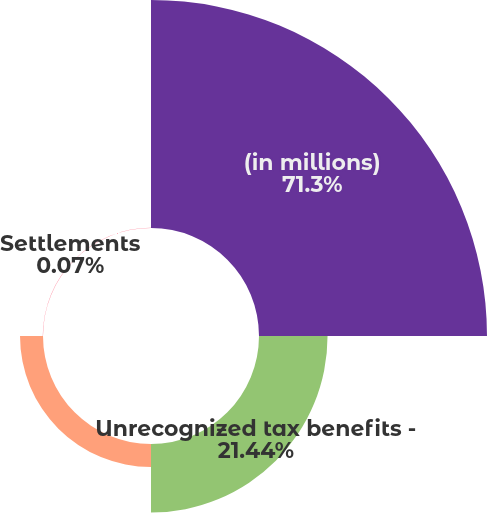Convert chart. <chart><loc_0><loc_0><loc_500><loc_500><pie_chart><fcel>(in millions)<fcel>Unrecognized tax benefits -<fcel>Current year tax positions<fcel>Settlements<nl><fcel>71.3%<fcel>21.44%<fcel>7.19%<fcel>0.07%<nl></chart> 